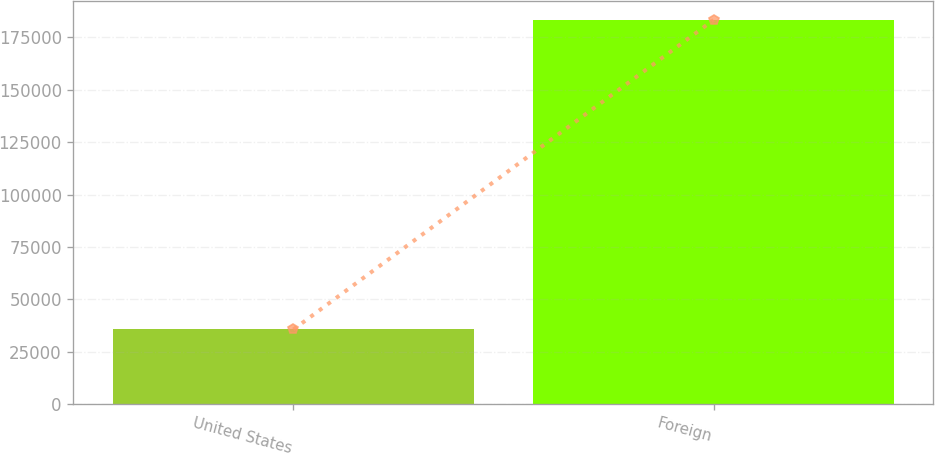<chart> <loc_0><loc_0><loc_500><loc_500><bar_chart><fcel>United States<fcel>Foreign<nl><fcel>35651<fcel>183338<nl></chart> 